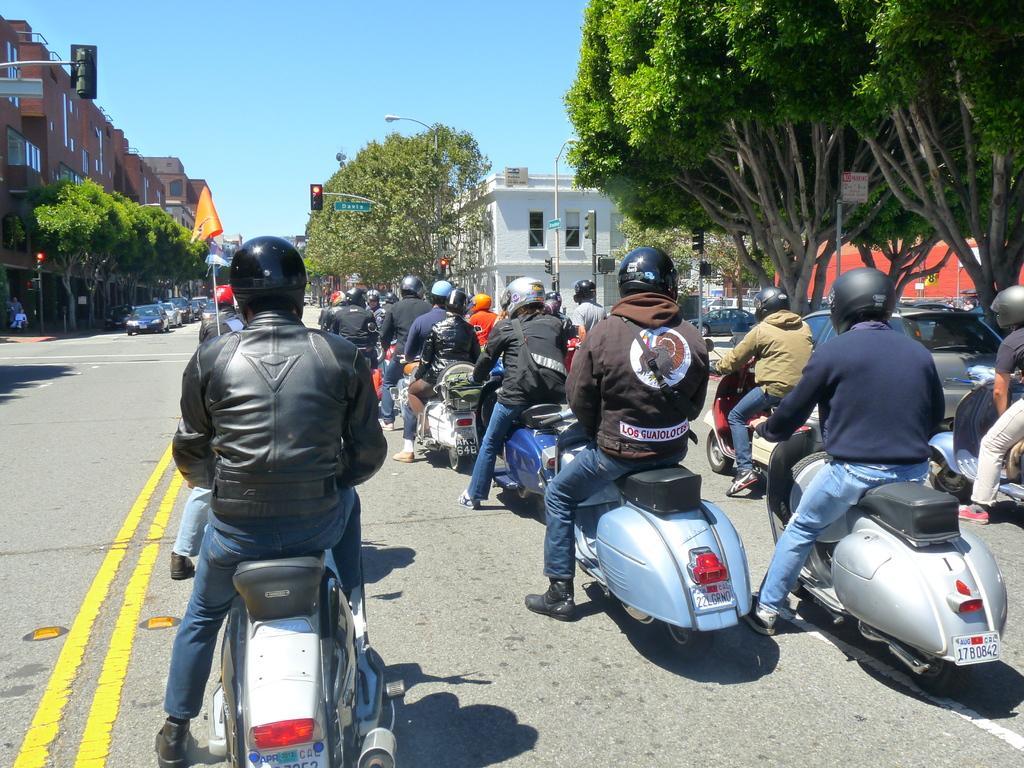How would you summarize this image in a sentence or two? In this image we can see so many people are on the scooter and they are wearing helmet. To the both sides of the image buildings and trees are present. 